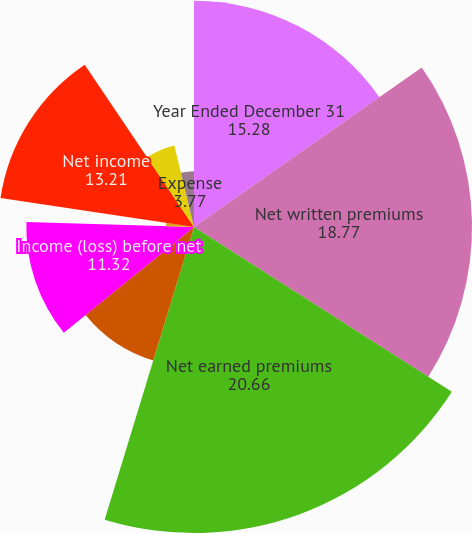Convert chart to OTSL. <chart><loc_0><loc_0><loc_500><loc_500><pie_chart><fcel>Year Ended December 31<fcel>Net written premiums<fcel>Net earned premiums<fcel>Net investment income<fcel>Income (loss) before net<fcel>Net realized investment gains<fcel>Net income<fcel>Loss and loss adjustment<fcel>Expense<fcel>Dividend<nl><fcel>15.28%<fcel>18.77%<fcel>20.66%<fcel>9.43%<fcel>11.32%<fcel>1.89%<fcel>13.21%<fcel>5.66%<fcel>3.77%<fcel>0.0%<nl></chart> 